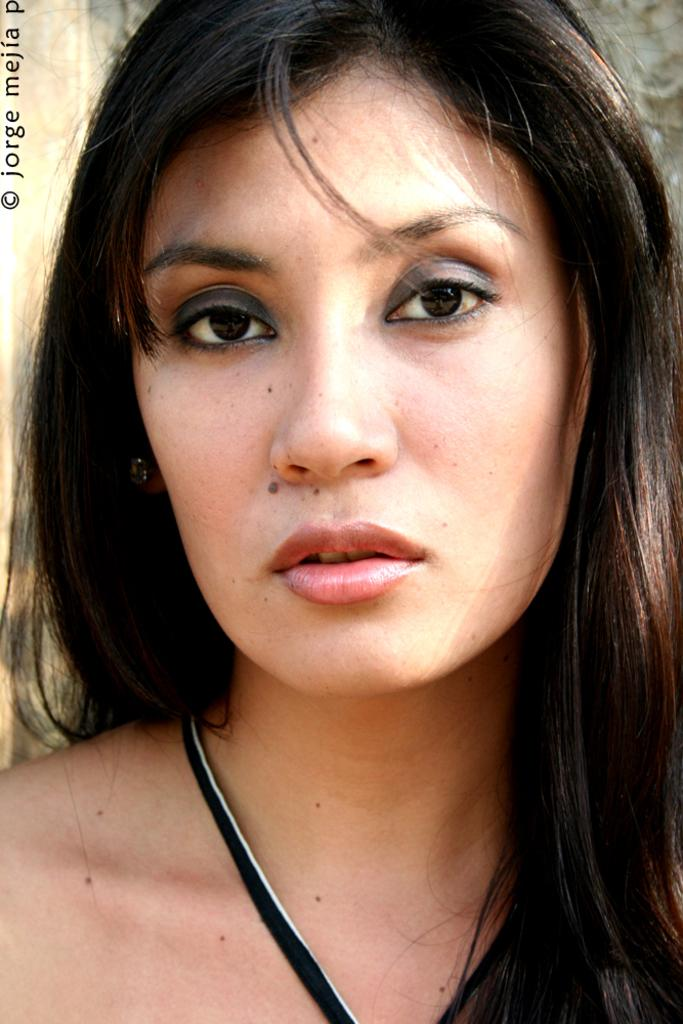Who is present in the image? There is a woman in the image. What type of credit does the woman have in the image? There is no information about the woman's credit in the image. What position does the woman hold in the image? There is no information about the woman's position in the image. 